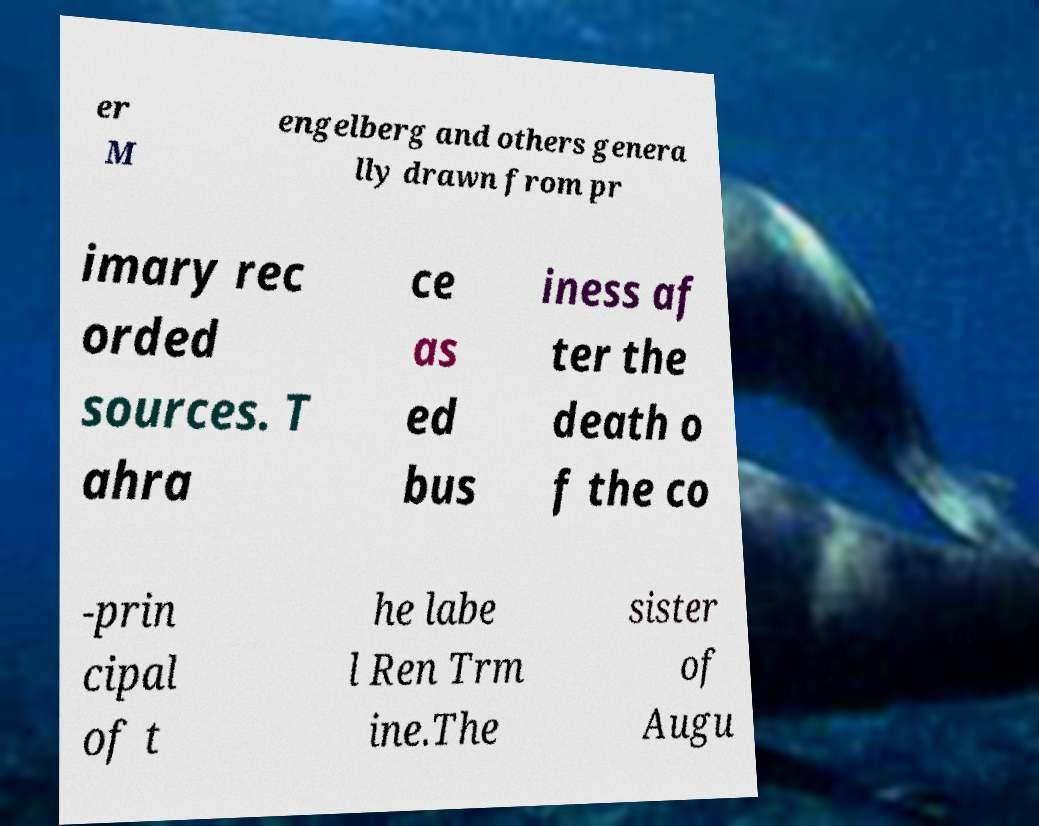What messages or text are displayed in this image? I need them in a readable, typed format. er M engelberg and others genera lly drawn from pr imary rec orded sources. T ahra ce as ed bus iness af ter the death o f the co -prin cipal of t he labe l Ren Trm ine.The sister of Augu 